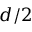<formula> <loc_0><loc_0><loc_500><loc_500>d / 2</formula> 